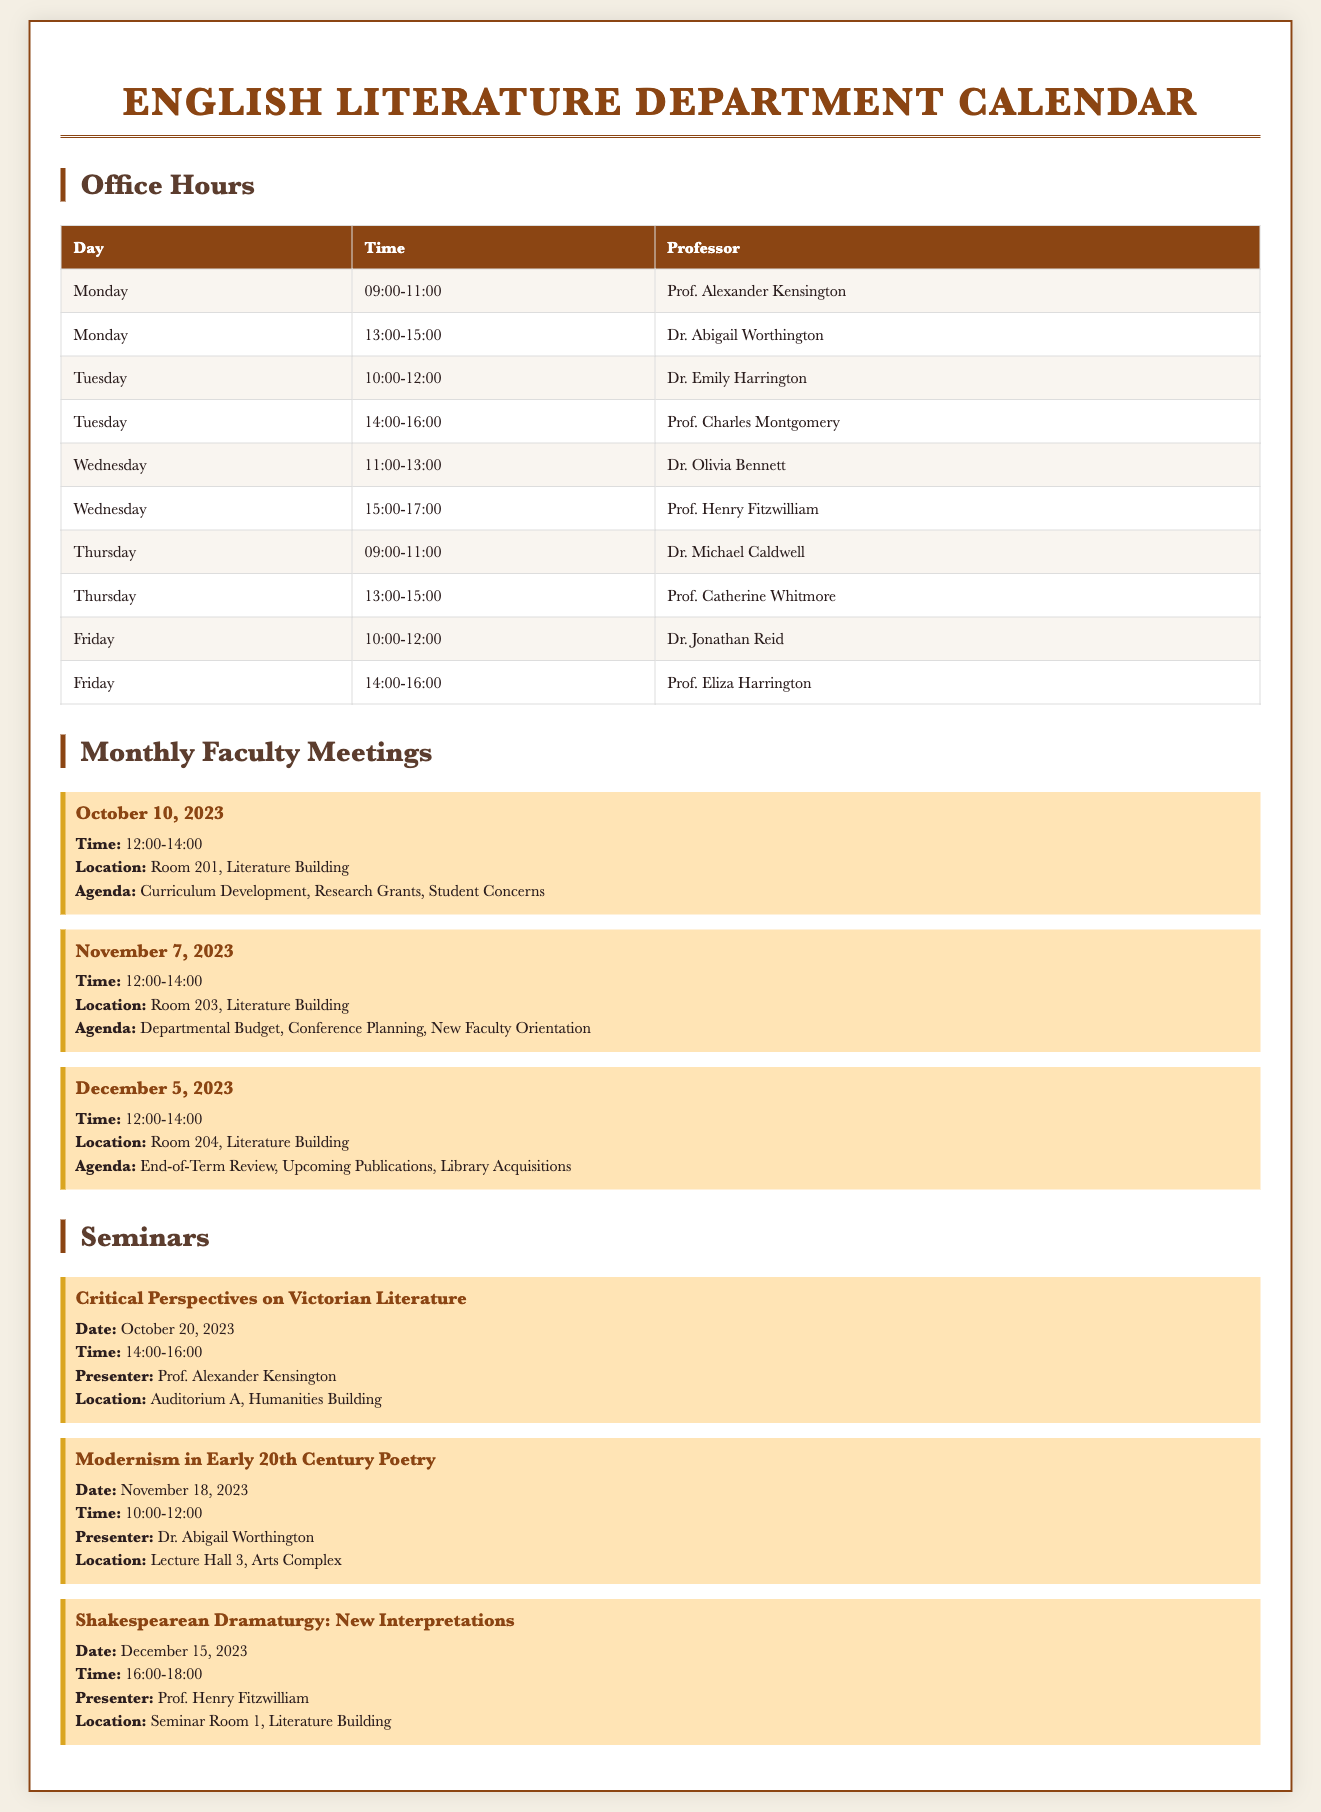what is the office hour for Dr. Emily Harrington? The office hours for Dr. Emily Harrington are on Tuesday from 10:00 to 12:00.
Answer: Tuesday 10:00-12:00 who presents the seminar on Modernism in Early 20th Century Poetry? The presenter for the seminar on Modernism in Early 20th Century Poetry is Dr. Abigail Worthington.
Answer: Dr. Abigail Worthington when is the next monthly faculty meeting after October 10, 2023? The next monthly faculty meeting after October 10, 2023, is on November 7, 2023.
Answer: November 7, 2023 what is the location for the seminar by Prof. Henry Fitzwilliam? The location for the seminar by Prof. Henry Fitzwilliam is Seminar Room 1, Literature Building.
Answer: Seminar Room 1, Literature Building how many office hours does Prof. Eliza Harrington have in total? Prof. Eliza Harrington has one office hour on Friday from 14:00 to 16:00.
Answer: 1 which seminar occurs in December 2023? The seminar that occurs in December 2023 is "Shakespearean Dramaturgy: New Interpretations."
Answer: Shakespearean Dramaturgy: New Interpretations what day of the week does Dr. Jonathan Reid hold office hours? Dr. Jonathan Reid holds office hours on Friday.
Answer: Friday what agenda item is listed for the November faculty meeting? An agenda item listed for the November faculty meeting is Conference Planning.
Answer: Conference Planning 